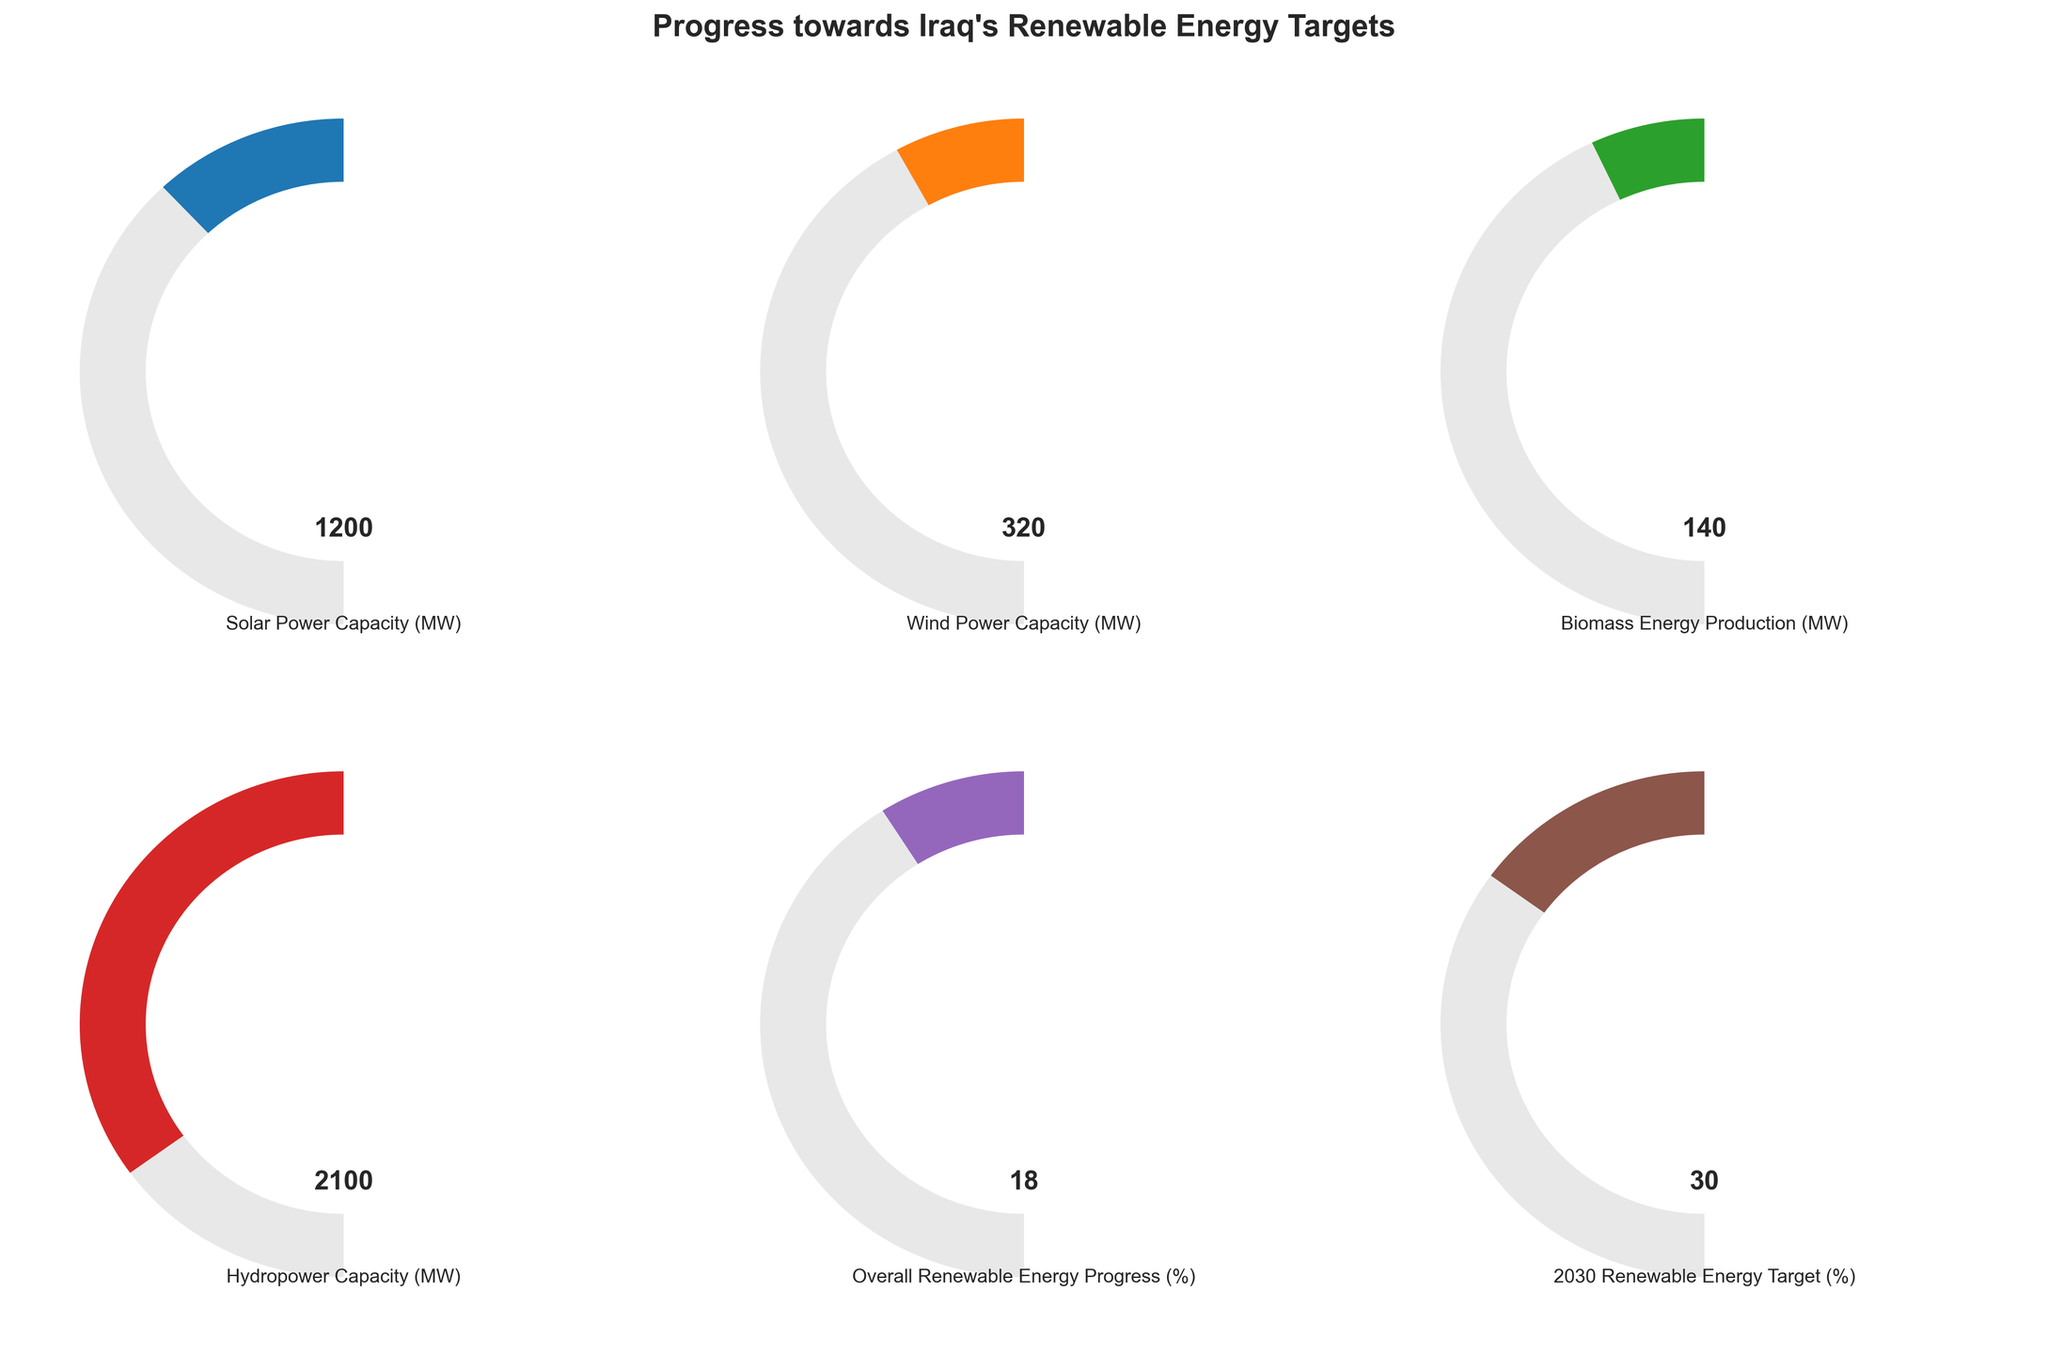What is the title of the figure? The title can be found at the top of the figure and reads "Progress towards Iraq's Renewable Energy Targets".
Answer: "Progress towards Iraq's Renewable Energy Targets" What is the value of Iraq's overall renewable energy progress percentage? The gauge for "Overall Renewable Energy Progress" shows a value of 18, which represents the percentage of Iraq's overall renewable energy progress.
Answer: 18% How much solar power capacity has been achieved compared to its maximum target? The solar power capacity achieved is 1200 MW out of a maximum target of 5000 MW, which can be calculated by directly referring to the gauge.
Answer: 1200 MW By what margin does Iraq need to increase its renewable energy progress to reach the 2030 target? Iraq's current renewable energy progress is at 18%, while the 2030 target is 30%. The difference between these two values is 30% - 18% = 12%.
Answer: 12% Which type of renewable energy source has reached the highest capacity? By comparing the gauges, the hydropower capacity has reached the highest value at 2100 MW.
Answer: Hydropower How does the achieved wind power capacity compare to its maximum target in percentage terms? The wind power capacity is 320 MW out of a maximum of 2000 MW. The percentage can be calculated as (320 / 2000) * 100 = 16%.
Answer: 16% What percentage of its biomass energy production target has Iraq achieved? The biomass energy production is 140 MW out of a target of 1000 MW. The percentage can be determined by (140 / 1000) * 100 = 14%.
Answer: 14% Is Iraq closer to its wind power or biomass energy production target? To compare, the wind power capacity is at 320 MW out of 2000 MW (16%), while biomass energy is 140 MW out of 1000 MW (14%). Since 16% > 14%, Iraq is closer to its wind power target.
Answer: Wind power Which two renewable energy types have achieved less than 20% of their target capacities? Both the wind power capacity (16%) and biomass energy production (14%) have achieved less than 20% of their target capacities.
Answer: Wind power and Biomass energy Which renewable energy source's gauge is the furthest from being filled? The wind power capacity gauge is at 320 MW out of an upper limit of 2000 MW, visualized as having the smallest filled segment compared with the other sources.
Answer: Wind power 